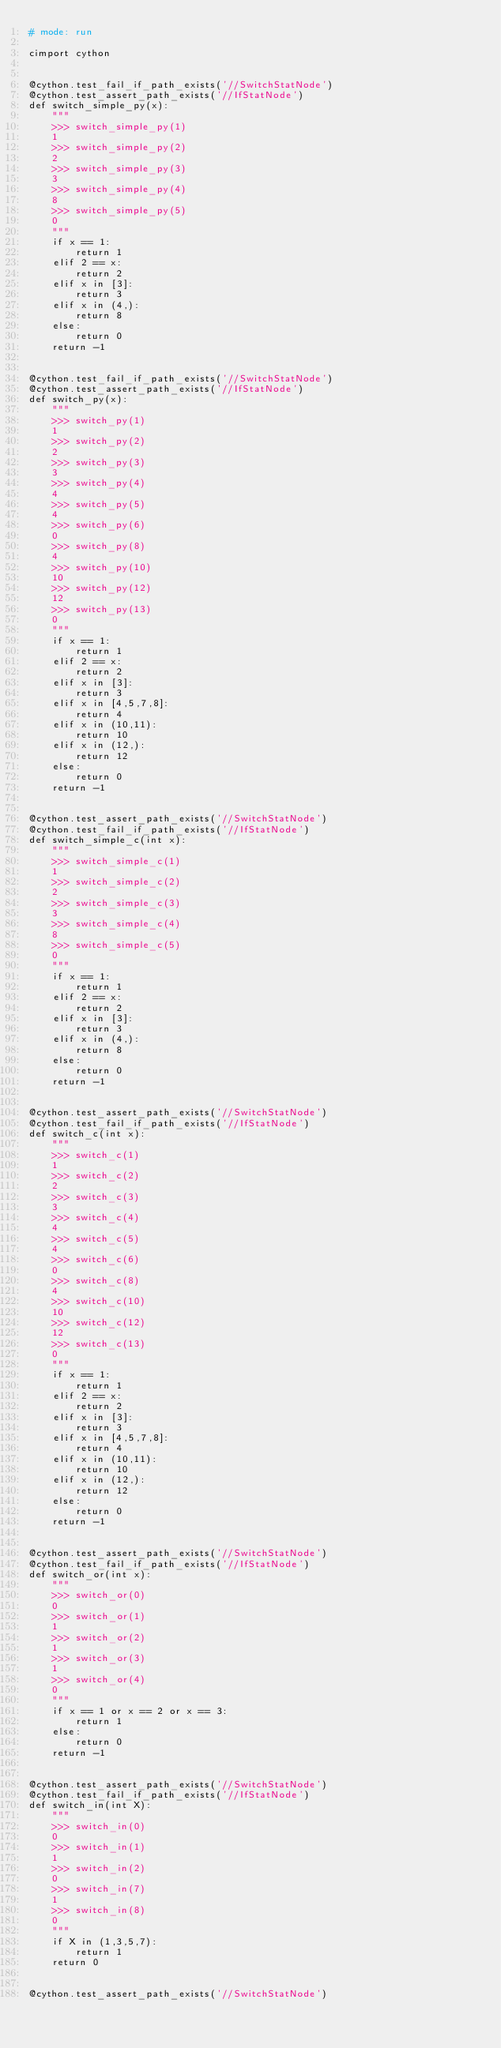Convert code to text. <code><loc_0><loc_0><loc_500><loc_500><_Cython_># mode: run

cimport cython


@cython.test_fail_if_path_exists('//SwitchStatNode')
@cython.test_assert_path_exists('//IfStatNode')
def switch_simple_py(x):
    """
    >>> switch_simple_py(1)
    1
    >>> switch_simple_py(2)
    2
    >>> switch_simple_py(3)
    3
    >>> switch_simple_py(4)
    8
    >>> switch_simple_py(5)
    0
    """
    if x == 1:
        return 1
    elif 2 == x:
        return 2
    elif x in [3]:
        return 3
    elif x in (4,):
        return 8
    else:
        return 0
    return -1


@cython.test_fail_if_path_exists('//SwitchStatNode')
@cython.test_assert_path_exists('//IfStatNode')
def switch_py(x):
    """
    >>> switch_py(1)
    1
    >>> switch_py(2)
    2
    >>> switch_py(3)
    3
    >>> switch_py(4)
    4
    >>> switch_py(5)
    4
    >>> switch_py(6)
    0
    >>> switch_py(8)
    4
    >>> switch_py(10)
    10
    >>> switch_py(12)
    12
    >>> switch_py(13)
    0
    """
    if x == 1:
        return 1
    elif 2 == x:
        return 2
    elif x in [3]:
        return 3
    elif x in [4,5,7,8]:
        return 4
    elif x in (10,11):
        return 10
    elif x in (12,):
        return 12
    else:
        return 0
    return -1


@cython.test_assert_path_exists('//SwitchStatNode')
@cython.test_fail_if_path_exists('//IfStatNode')
def switch_simple_c(int x):
    """
    >>> switch_simple_c(1)
    1
    >>> switch_simple_c(2)
    2
    >>> switch_simple_c(3)
    3
    >>> switch_simple_c(4)
    8
    >>> switch_simple_c(5)
    0
    """
    if x == 1:
        return 1
    elif 2 == x:
        return 2
    elif x in [3]:
        return 3
    elif x in (4,):
        return 8
    else:
        return 0
    return -1


@cython.test_assert_path_exists('//SwitchStatNode')
@cython.test_fail_if_path_exists('//IfStatNode')
def switch_c(int x):
    """
    >>> switch_c(1)
    1
    >>> switch_c(2)
    2
    >>> switch_c(3)
    3
    >>> switch_c(4)
    4
    >>> switch_c(5)
    4
    >>> switch_c(6)
    0
    >>> switch_c(8)
    4
    >>> switch_c(10)
    10
    >>> switch_c(12)
    12
    >>> switch_c(13)
    0
    """
    if x == 1:
        return 1
    elif 2 == x:
        return 2
    elif x in [3]:
        return 3
    elif x in [4,5,7,8]:
        return 4
    elif x in (10,11):
        return 10
    elif x in (12,):
        return 12
    else:
        return 0
    return -1


@cython.test_assert_path_exists('//SwitchStatNode')
@cython.test_fail_if_path_exists('//IfStatNode')
def switch_or(int x):
    """
    >>> switch_or(0)
    0
    >>> switch_or(1)
    1
    >>> switch_or(2)
    1
    >>> switch_or(3)
    1
    >>> switch_or(4)
    0
    """
    if x == 1 or x == 2 or x == 3:
        return 1
    else:
        return 0
    return -1


@cython.test_assert_path_exists('//SwitchStatNode')
@cython.test_fail_if_path_exists('//IfStatNode')
def switch_in(int X):
    """
    >>> switch_in(0)
    0
    >>> switch_in(1)
    1
    >>> switch_in(2)
    0
    >>> switch_in(7)
    1
    >>> switch_in(8)
    0
    """
    if X in (1,3,5,7):
        return 1
    return 0


@cython.test_assert_path_exists('//SwitchStatNode')</code> 